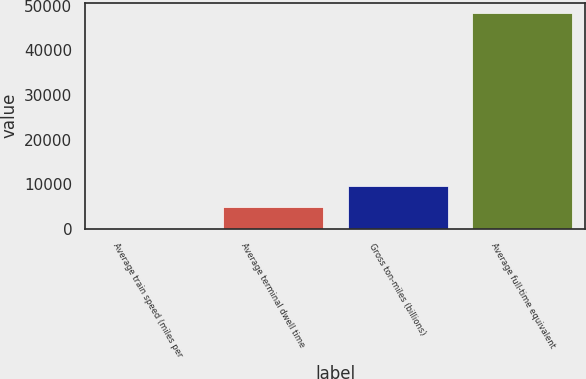Convert chart to OTSL. <chart><loc_0><loc_0><loc_500><loc_500><bar_chart><fcel>Average train speed (miles per<fcel>Average terminal dwell time<fcel>Gross ton-miles (billions)<fcel>Average full-time equivalent<nl><fcel>21.4<fcel>4852.16<fcel>9682.92<fcel>48329<nl></chart> 